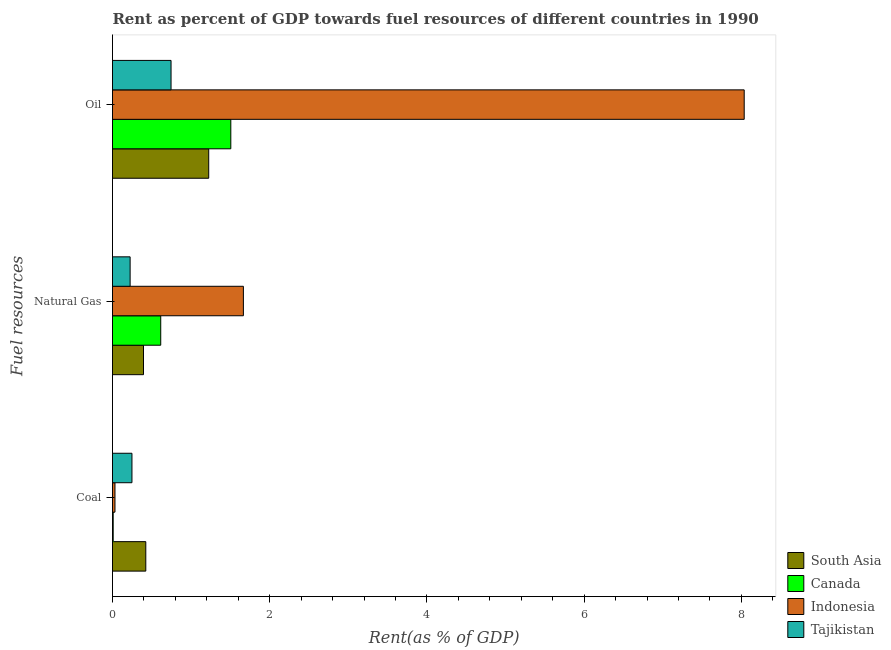Are the number of bars per tick equal to the number of legend labels?
Give a very brief answer. Yes. How many bars are there on the 2nd tick from the bottom?
Give a very brief answer. 4. What is the label of the 1st group of bars from the top?
Provide a succinct answer. Oil. What is the rent towards natural gas in Canada?
Provide a succinct answer. 0.61. Across all countries, what is the maximum rent towards oil?
Your response must be concise. 8.04. Across all countries, what is the minimum rent towards natural gas?
Provide a short and direct response. 0.22. In which country was the rent towards coal minimum?
Provide a succinct answer. Canada. What is the total rent towards natural gas in the graph?
Offer a terse response. 2.9. What is the difference between the rent towards coal in South Asia and that in Tajikistan?
Give a very brief answer. 0.18. What is the difference between the rent towards oil in Tajikistan and the rent towards coal in South Asia?
Offer a terse response. 0.32. What is the average rent towards coal per country?
Provide a succinct answer. 0.18. What is the difference between the rent towards natural gas and rent towards oil in Tajikistan?
Your response must be concise. -0.52. What is the ratio of the rent towards natural gas in Indonesia to that in Tajikistan?
Provide a succinct answer. 7.43. Is the difference between the rent towards coal in South Asia and Indonesia greater than the difference between the rent towards oil in South Asia and Indonesia?
Your answer should be compact. Yes. What is the difference between the highest and the second highest rent towards natural gas?
Ensure brevity in your answer.  1.05. What is the difference between the highest and the lowest rent towards natural gas?
Make the answer very short. 1.44. Is the sum of the rent towards oil in Tajikistan and Canada greater than the maximum rent towards natural gas across all countries?
Provide a succinct answer. Yes. What does the 2nd bar from the top in Coal represents?
Provide a short and direct response. Indonesia. What does the 1st bar from the bottom in Oil represents?
Offer a terse response. South Asia. How many bars are there?
Make the answer very short. 12. How many legend labels are there?
Provide a succinct answer. 4. What is the title of the graph?
Offer a very short reply. Rent as percent of GDP towards fuel resources of different countries in 1990. Does "Brunei Darussalam" appear as one of the legend labels in the graph?
Provide a short and direct response. No. What is the label or title of the X-axis?
Keep it short and to the point. Rent(as % of GDP). What is the label or title of the Y-axis?
Keep it short and to the point. Fuel resources. What is the Rent(as % of GDP) of South Asia in Coal?
Offer a very short reply. 0.42. What is the Rent(as % of GDP) in Canada in Coal?
Provide a short and direct response. 0.01. What is the Rent(as % of GDP) of Indonesia in Coal?
Make the answer very short. 0.03. What is the Rent(as % of GDP) in Tajikistan in Coal?
Provide a short and direct response. 0.25. What is the Rent(as % of GDP) in South Asia in Natural Gas?
Your response must be concise. 0.39. What is the Rent(as % of GDP) of Canada in Natural Gas?
Your answer should be very brief. 0.61. What is the Rent(as % of GDP) in Indonesia in Natural Gas?
Your response must be concise. 1.67. What is the Rent(as % of GDP) in Tajikistan in Natural Gas?
Provide a succinct answer. 0.22. What is the Rent(as % of GDP) in South Asia in Oil?
Your answer should be very brief. 1.22. What is the Rent(as % of GDP) in Canada in Oil?
Your response must be concise. 1.5. What is the Rent(as % of GDP) of Indonesia in Oil?
Offer a very short reply. 8.04. What is the Rent(as % of GDP) in Tajikistan in Oil?
Give a very brief answer. 0.74. Across all Fuel resources, what is the maximum Rent(as % of GDP) in South Asia?
Ensure brevity in your answer.  1.22. Across all Fuel resources, what is the maximum Rent(as % of GDP) of Canada?
Ensure brevity in your answer.  1.5. Across all Fuel resources, what is the maximum Rent(as % of GDP) of Indonesia?
Your answer should be compact. 8.04. Across all Fuel resources, what is the maximum Rent(as % of GDP) of Tajikistan?
Your answer should be very brief. 0.74. Across all Fuel resources, what is the minimum Rent(as % of GDP) in South Asia?
Give a very brief answer. 0.39. Across all Fuel resources, what is the minimum Rent(as % of GDP) of Canada?
Provide a short and direct response. 0.01. Across all Fuel resources, what is the minimum Rent(as % of GDP) in Indonesia?
Give a very brief answer. 0.03. Across all Fuel resources, what is the minimum Rent(as % of GDP) of Tajikistan?
Give a very brief answer. 0.22. What is the total Rent(as % of GDP) in South Asia in the graph?
Your response must be concise. 2.04. What is the total Rent(as % of GDP) of Canada in the graph?
Make the answer very short. 2.13. What is the total Rent(as % of GDP) in Indonesia in the graph?
Ensure brevity in your answer.  9.73. What is the total Rent(as % of GDP) in Tajikistan in the graph?
Your response must be concise. 1.22. What is the difference between the Rent(as % of GDP) of South Asia in Coal and that in Natural Gas?
Provide a succinct answer. 0.03. What is the difference between the Rent(as % of GDP) of Canada in Coal and that in Natural Gas?
Offer a very short reply. -0.6. What is the difference between the Rent(as % of GDP) in Indonesia in Coal and that in Natural Gas?
Offer a very short reply. -1.63. What is the difference between the Rent(as % of GDP) in Tajikistan in Coal and that in Natural Gas?
Keep it short and to the point. 0.02. What is the difference between the Rent(as % of GDP) in South Asia in Coal and that in Oil?
Give a very brief answer. -0.8. What is the difference between the Rent(as % of GDP) in Canada in Coal and that in Oil?
Make the answer very short. -1.5. What is the difference between the Rent(as % of GDP) in Indonesia in Coal and that in Oil?
Offer a terse response. -8. What is the difference between the Rent(as % of GDP) of Tajikistan in Coal and that in Oil?
Provide a short and direct response. -0.5. What is the difference between the Rent(as % of GDP) of South Asia in Natural Gas and that in Oil?
Keep it short and to the point. -0.83. What is the difference between the Rent(as % of GDP) in Canada in Natural Gas and that in Oil?
Provide a succinct answer. -0.89. What is the difference between the Rent(as % of GDP) of Indonesia in Natural Gas and that in Oil?
Ensure brevity in your answer.  -6.37. What is the difference between the Rent(as % of GDP) of Tajikistan in Natural Gas and that in Oil?
Provide a succinct answer. -0.52. What is the difference between the Rent(as % of GDP) in South Asia in Coal and the Rent(as % of GDP) in Canada in Natural Gas?
Keep it short and to the point. -0.19. What is the difference between the Rent(as % of GDP) of South Asia in Coal and the Rent(as % of GDP) of Indonesia in Natural Gas?
Provide a succinct answer. -1.24. What is the difference between the Rent(as % of GDP) in South Asia in Coal and the Rent(as % of GDP) in Tajikistan in Natural Gas?
Offer a terse response. 0.2. What is the difference between the Rent(as % of GDP) in Canada in Coal and the Rent(as % of GDP) in Indonesia in Natural Gas?
Provide a short and direct response. -1.66. What is the difference between the Rent(as % of GDP) of Canada in Coal and the Rent(as % of GDP) of Tajikistan in Natural Gas?
Ensure brevity in your answer.  -0.22. What is the difference between the Rent(as % of GDP) of Indonesia in Coal and the Rent(as % of GDP) of Tajikistan in Natural Gas?
Your answer should be compact. -0.19. What is the difference between the Rent(as % of GDP) of South Asia in Coal and the Rent(as % of GDP) of Canada in Oil?
Keep it short and to the point. -1.08. What is the difference between the Rent(as % of GDP) in South Asia in Coal and the Rent(as % of GDP) in Indonesia in Oil?
Ensure brevity in your answer.  -7.61. What is the difference between the Rent(as % of GDP) in South Asia in Coal and the Rent(as % of GDP) in Tajikistan in Oil?
Offer a terse response. -0.32. What is the difference between the Rent(as % of GDP) of Canada in Coal and the Rent(as % of GDP) of Indonesia in Oil?
Offer a very short reply. -8.03. What is the difference between the Rent(as % of GDP) of Canada in Coal and the Rent(as % of GDP) of Tajikistan in Oil?
Your response must be concise. -0.74. What is the difference between the Rent(as % of GDP) in Indonesia in Coal and the Rent(as % of GDP) in Tajikistan in Oil?
Ensure brevity in your answer.  -0.71. What is the difference between the Rent(as % of GDP) in South Asia in Natural Gas and the Rent(as % of GDP) in Canada in Oil?
Provide a short and direct response. -1.11. What is the difference between the Rent(as % of GDP) in South Asia in Natural Gas and the Rent(as % of GDP) in Indonesia in Oil?
Offer a terse response. -7.64. What is the difference between the Rent(as % of GDP) of South Asia in Natural Gas and the Rent(as % of GDP) of Tajikistan in Oil?
Ensure brevity in your answer.  -0.35. What is the difference between the Rent(as % of GDP) in Canada in Natural Gas and the Rent(as % of GDP) in Indonesia in Oil?
Offer a terse response. -7.42. What is the difference between the Rent(as % of GDP) of Canada in Natural Gas and the Rent(as % of GDP) of Tajikistan in Oil?
Your response must be concise. -0.13. What is the difference between the Rent(as % of GDP) of Indonesia in Natural Gas and the Rent(as % of GDP) of Tajikistan in Oil?
Offer a terse response. 0.92. What is the average Rent(as % of GDP) of South Asia per Fuel resources?
Give a very brief answer. 0.68. What is the average Rent(as % of GDP) of Canada per Fuel resources?
Your response must be concise. 0.71. What is the average Rent(as % of GDP) in Indonesia per Fuel resources?
Your answer should be very brief. 3.24. What is the average Rent(as % of GDP) of Tajikistan per Fuel resources?
Your answer should be very brief. 0.41. What is the difference between the Rent(as % of GDP) in South Asia and Rent(as % of GDP) in Canada in Coal?
Keep it short and to the point. 0.41. What is the difference between the Rent(as % of GDP) of South Asia and Rent(as % of GDP) of Indonesia in Coal?
Make the answer very short. 0.39. What is the difference between the Rent(as % of GDP) in South Asia and Rent(as % of GDP) in Tajikistan in Coal?
Offer a very short reply. 0.18. What is the difference between the Rent(as % of GDP) of Canada and Rent(as % of GDP) of Indonesia in Coal?
Keep it short and to the point. -0.02. What is the difference between the Rent(as % of GDP) of Canada and Rent(as % of GDP) of Tajikistan in Coal?
Your answer should be compact. -0.24. What is the difference between the Rent(as % of GDP) of Indonesia and Rent(as % of GDP) of Tajikistan in Coal?
Your answer should be very brief. -0.22. What is the difference between the Rent(as % of GDP) of South Asia and Rent(as % of GDP) of Canada in Natural Gas?
Provide a succinct answer. -0.22. What is the difference between the Rent(as % of GDP) in South Asia and Rent(as % of GDP) in Indonesia in Natural Gas?
Provide a succinct answer. -1.27. What is the difference between the Rent(as % of GDP) in South Asia and Rent(as % of GDP) in Tajikistan in Natural Gas?
Make the answer very short. 0.17. What is the difference between the Rent(as % of GDP) in Canada and Rent(as % of GDP) in Indonesia in Natural Gas?
Provide a succinct answer. -1.05. What is the difference between the Rent(as % of GDP) of Canada and Rent(as % of GDP) of Tajikistan in Natural Gas?
Offer a very short reply. 0.39. What is the difference between the Rent(as % of GDP) in Indonesia and Rent(as % of GDP) in Tajikistan in Natural Gas?
Make the answer very short. 1.44. What is the difference between the Rent(as % of GDP) in South Asia and Rent(as % of GDP) in Canada in Oil?
Make the answer very short. -0.28. What is the difference between the Rent(as % of GDP) of South Asia and Rent(as % of GDP) of Indonesia in Oil?
Your answer should be very brief. -6.81. What is the difference between the Rent(as % of GDP) of South Asia and Rent(as % of GDP) of Tajikistan in Oil?
Make the answer very short. 0.48. What is the difference between the Rent(as % of GDP) in Canada and Rent(as % of GDP) in Indonesia in Oil?
Offer a very short reply. -6.53. What is the difference between the Rent(as % of GDP) of Canada and Rent(as % of GDP) of Tajikistan in Oil?
Provide a succinct answer. 0.76. What is the difference between the Rent(as % of GDP) in Indonesia and Rent(as % of GDP) in Tajikistan in Oil?
Offer a terse response. 7.29. What is the ratio of the Rent(as % of GDP) in South Asia in Coal to that in Natural Gas?
Give a very brief answer. 1.07. What is the ratio of the Rent(as % of GDP) in Canada in Coal to that in Natural Gas?
Your answer should be compact. 0.01. What is the ratio of the Rent(as % of GDP) of Indonesia in Coal to that in Natural Gas?
Your answer should be very brief. 0.02. What is the ratio of the Rent(as % of GDP) of Tajikistan in Coal to that in Natural Gas?
Your answer should be very brief. 1.1. What is the ratio of the Rent(as % of GDP) in South Asia in Coal to that in Oil?
Your answer should be compact. 0.35. What is the ratio of the Rent(as % of GDP) of Canada in Coal to that in Oil?
Give a very brief answer. 0.01. What is the ratio of the Rent(as % of GDP) of Indonesia in Coal to that in Oil?
Offer a very short reply. 0. What is the ratio of the Rent(as % of GDP) in Tajikistan in Coal to that in Oil?
Your answer should be compact. 0.33. What is the ratio of the Rent(as % of GDP) of South Asia in Natural Gas to that in Oil?
Offer a terse response. 0.32. What is the ratio of the Rent(as % of GDP) of Canada in Natural Gas to that in Oil?
Provide a short and direct response. 0.41. What is the ratio of the Rent(as % of GDP) of Indonesia in Natural Gas to that in Oil?
Provide a short and direct response. 0.21. What is the ratio of the Rent(as % of GDP) of Tajikistan in Natural Gas to that in Oil?
Give a very brief answer. 0.3. What is the difference between the highest and the second highest Rent(as % of GDP) of South Asia?
Your answer should be very brief. 0.8. What is the difference between the highest and the second highest Rent(as % of GDP) of Canada?
Give a very brief answer. 0.89. What is the difference between the highest and the second highest Rent(as % of GDP) in Indonesia?
Offer a terse response. 6.37. What is the difference between the highest and the second highest Rent(as % of GDP) of Tajikistan?
Offer a terse response. 0.5. What is the difference between the highest and the lowest Rent(as % of GDP) in South Asia?
Ensure brevity in your answer.  0.83. What is the difference between the highest and the lowest Rent(as % of GDP) of Canada?
Your answer should be very brief. 1.5. What is the difference between the highest and the lowest Rent(as % of GDP) in Indonesia?
Ensure brevity in your answer.  8. What is the difference between the highest and the lowest Rent(as % of GDP) in Tajikistan?
Offer a terse response. 0.52. 